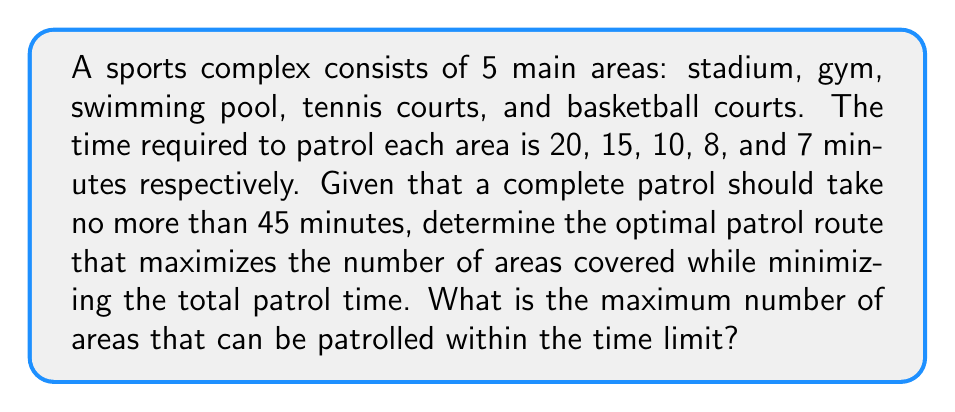Teach me how to tackle this problem. To solve this problem, we need to use a combination of the Knapsack problem and route optimization techniques. Let's approach this step-by-step:

1) First, list all areas with their patrol times:
   Stadium (S): 20 minutes
   Gym (G): 15 minutes
   Swimming Pool (P): 10 minutes
   Tennis Courts (T): 8 minutes
   Basketball Courts (B): 7 minutes

2) The goal is to maximize the number of areas covered within 45 minutes.

3) Start by sorting the areas in ascending order of patrol time:
   B (7), T (8), P (10), G (15), S (20)

4) Now, let's try different combinations:
   B + T + P = 7 + 8 + 10 = 25 minutes (3 areas)
   B + T + P + G = 7 + 8 + 10 + 15 = 40 minutes (4 areas)
   B + T + P + G + S = 7 + 8 + 10 + 15 + 20 = 60 minutes (exceeds limit)

5) The optimal solution is to patrol 4 areas: B, T, P, and G, which takes 40 minutes.

6) The route can be optimized to minimize transitions, for example:
   Gym → Tennis Courts → Basketball Courts → Swimming Pool

This route covers the maximum number of areas (4) within the time limit, leaving a 5-minute buffer for transitions between areas.
Answer: 4 areas 